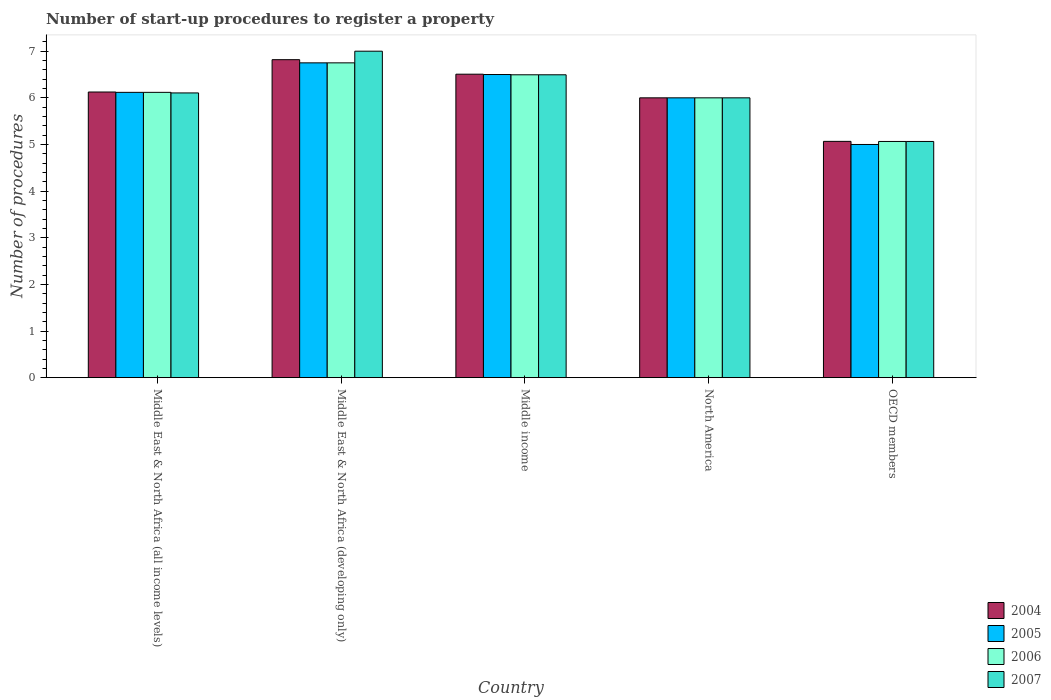How many different coloured bars are there?
Your answer should be compact. 4. Are the number of bars per tick equal to the number of legend labels?
Offer a terse response. Yes. Are the number of bars on each tick of the X-axis equal?
Offer a very short reply. Yes. How many bars are there on the 2nd tick from the right?
Ensure brevity in your answer.  4. What is the label of the 4th group of bars from the left?
Make the answer very short. North America. In how many cases, is the number of bars for a given country not equal to the number of legend labels?
Ensure brevity in your answer.  0. What is the number of procedures required to register a property in 2007 in Middle East & North Africa (all income levels)?
Provide a succinct answer. 6.11. Across all countries, what is the maximum number of procedures required to register a property in 2004?
Provide a succinct answer. 6.82. Across all countries, what is the minimum number of procedures required to register a property in 2006?
Your response must be concise. 5.06. In which country was the number of procedures required to register a property in 2006 maximum?
Keep it short and to the point. Middle East & North Africa (developing only). In which country was the number of procedures required to register a property in 2005 minimum?
Provide a short and direct response. OECD members. What is the total number of procedures required to register a property in 2006 in the graph?
Offer a very short reply. 30.43. What is the difference between the number of procedures required to register a property in 2004 in Middle income and that in North America?
Your answer should be very brief. 0.51. What is the difference between the number of procedures required to register a property in 2007 in Middle income and the number of procedures required to register a property in 2004 in Middle East & North Africa (developing only)?
Offer a very short reply. -0.32. What is the average number of procedures required to register a property in 2005 per country?
Your answer should be compact. 6.07. Is the number of procedures required to register a property in 2004 in Middle East & North Africa (all income levels) less than that in Middle East & North Africa (developing only)?
Provide a succinct answer. Yes. Is the difference between the number of procedures required to register a property in 2005 in Middle income and OECD members greater than the difference between the number of procedures required to register a property in 2006 in Middle income and OECD members?
Offer a very short reply. Yes. What is the difference between the highest and the second highest number of procedures required to register a property in 2005?
Give a very brief answer. -0.63. What is the difference between the highest and the lowest number of procedures required to register a property in 2007?
Offer a very short reply. 1.94. In how many countries, is the number of procedures required to register a property in 2007 greater than the average number of procedures required to register a property in 2007 taken over all countries?
Give a very brief answer. 2. Is it the case that in every country, the sum of the number of procedures required to register a property in 2005 and number of procedures required to register a property in 2007 is greater than the number of procedures required to register a property in 2004?
Your answer should be compact. Yes. How many bars are there?
Your answer should be compact. 20. Are all the bars in the graph horizontal?
Provide a succinct answer. No. How many countries are there in the graph?
Make the answer very short. 5. What is the difference between two consecutive major ticks on the Y-axis?
Provide a succinct answer. 1. Where does the legend appear in the graph?
Give a very brief answer. Bottom right. How many legend labels are there?
Provide a succinct answer. 4. What is the title of the graph?
Offer a terse response. Number of start-up procedures to register a property. What is the label or title of the X-axis?
Provide a short and direct response. Country. What is the label or title of the Y-axis?
Provide a succinct answer. Number of procedures. What is the Number of procedures of 2004 in Middle East & North Africa (all income levels)?
Give a very brief answer. 6.12. What is the Number of procedures in 2005 in Middle East & North Africa (all income levels)?
Your answer should be very brief. 6.12. What is the Number of procedures in 2006 in Middle East & North Africa (all income levels)?
Offer a terse response. 6.12. What is the Number of procedures of 2007 in Middle East & North Africa (all income levels)?
Offer a terse response. 6.11. What is the Number of procedures of 2004 in Middle East & North Africa (developing only)?
Your answer should be very brief. 6.82. What is the Number of procedures of 2005 in Middle East & North Africa (developing only)?
Ensure brevity in your answer.  6.75. What is the Number of procedures in 2006 in Middle East & North Africa (developing only)?
Make the answer very short. 6.75. What is the Number of procedures in 2007 in Middle East & North Africa (developing only)?
Offer a terse response. 7. What is the Number of procedures in 2004 in Middle income?
Provide a succinct answer. 6.51. What is the Number of procedures of 2005 in Middle income?
Offer a terse response. 6.5. What is the Number of procedures in 2006 in Middle income?
Your response must be concise. 6.49. What is the Number of procedures in 2007 in Middle income?
Provide a succinct answer. 6.49. What is the Number of procedures in 2004 in OECD members?
Give a very brief answer. 5.07. What is the Number of procedures of 2005 in OECD members?
Provide a short and direct response. 5. What is the Number of procedures of 2006 in OECD members?
Provide a short and direct response. 5.06. What is the Number of procedures of 2007 in OECD members?
Provide a short and direct response. 5.06. Across all countries, what is the maximum Number of procedures in 2004?
Your answer should be very brief. 6.82. Across all countries, what is the maximum Number of procedures of 2005?
Offer a very short reply. 6.75. Across all countries, what is the maximum Number of procedures of 2006?
Offer a very short reply. 6.75. Across all countries, what is the maximum Number of procedures of 2007?
Offer a terse response. 7. Across all countries, what is the minimum Number of procedures in 2004?
Your answer should be very brief. 5.07. Across all countries, what is the minimum Number of procedures in 2005?
Your response must be concise. 5. Across all countries, what is the minimum Number of procedures of 2006?
Make the answer very short. 5.06. Across all countries, what is the minimum Number of procedures in 2007?
Provide a short and direct response. 5.06. What is the total Number of procedures in 2004 in the graph?
Make the answer very short. 30.52. What is the total Number of procedures in 2005 in the graph?
Keep it short and to the point. 30.37. What is the total Number of procedures of 2006 in the graph?
Make the answer very short. 30.43. What is the total Number of procedures in 2007 in the graph?
Ensure brevity in your answer.  30.66. What is the difference between the Number of procedures in 2004 in Middle East & North Africa (all income levels) and that in Middle East & North Africa (developing only)?
Your answer should be compact. -0.69. What is the difference between the Number of procedures of 2005 in Middle East & North Africa (all income levels) and that in Middle East & North Africa (developing only)?
Make the answer very short. -0.63. What is the difference between the Number of procedures in 2006 in Middle East & North Africa (all income levels) and that in Middle East & North Africa (developing only)?
Provide a short and direct response. -0.63. What is the difference between the Number of procedures in 2007 in Middle East & North Africa (all income levels) and that in Middle East & North Africa (developing only)?
Keep it short and to the point. -0.89. What is the difference between the Number of procedures of 2004 in Middle East & North Africa (all income levels) and that in Middle income?
Give a very brief answer. -0.38. What is the difference between the Number of procedures of 2005 in Middle East & North Africa (all income levels) and that in Middle income?
Keep it short and to the point. -0.38. What is the difference between the Number of procedures of 2006 in Middle East & North Africa (all income levels) and that in Middle income?
Your answer should be compact. -0.38. What is the difference between the Number of procedures in 2007 in Middle East & North Africa (all income levels) and that in Middle income?
Ensure brevity in your answer.  -0.39. What is the difference between the Number of procedures of 2004 in Middle East & North Africa (all income levels) and that in North America?
Offer a very short reply. 0.12. What is the difference between the Number of procedures of 2005 in Middle East & North Africa (all income levels) and that in North America?
Offer a very short reply. 0.12. What is the difference between the Number of procedures of 2006 in Middle East & North Africa (all income levels) and that in North America?
Provide a short and direct response. 0.12. What is the difference between the Number of procedures in 2007 in Middle East & North Africa (all income levels) and that in North America?
Provide a short and direct response. 0.11. What is the difference between the Number of procedures in 2004 in Middle East & North Africa (all income levels) and that in OECD members?
Provide a short and direct response. 1.06. What is the difference between the Number of procedures of 2005 in Middle East & North Africa (all income levels) and that in OECD members?
Provide a short and direct response. 1.12. What is the difference between the Number of procedures in 2006 in Middle East & North Africa (all income levels) and that in OECD members?
Your answer should be compact. 1.05. What is the difference between the Number of procedures in 2007 in Middle East & North Africa (all income levels) and that in OECD members?
Ensure brevity in your answer.  1.04. What is the difference between the Number of procedures of 2004 in Middle East & North Africa (developing only) and that in Middle income?
Offer a terse response. 0.31. What is the difference between the Number of procedures in 2006 in Middle East & North Africa (developing only) and that in Middle income?
Your answer should be compact. 0.26. What is the difference between the Number of procedures in 2007 in Middle East & North Africa (developing only) and that in Middle income?
Provide a succinct answer. 0.51. What is the difference between the Number of procedures in 2004 in Middle East & North Africa (developing only) and that in North America?
Your answer should be compact. 0.82. What is the difference between the Number of procedures of 2006 in Middle East & North Africa (developing only) and that in North America?
Provide a short and direct response. 0.75. What is the difference between the Number of procedures in 2004 in Middle East & North Africa (developing only) and that in OECD members?
Keep it short and to the point. 1.75. What is the difference between the Number of procedures in 2005 in Middle East & North Africa (developing only) and that in OECD members?
Offer a terse response. 1.75. What is the difference between the Number of procedures in 2006 in Middle East & North Africa (developing only) and that in OECD members?
Offer a terse response. 1.69. What is the difference between the Number of procedures of 2007 in Middle East & North Africa (developing only) and that in OECD members?
Your answer should be compact. 1.94. What is the difference between the Number of procedures of 2004 in Middle income and that in North America?
Offer a very short reply. 0.51. What is the difference between the Number of procedures in 2006 in Middle income and that in North America?
Your answer should be very brief. 0.49. What is the difference between the Number of procedures of 2007 in Middle income and that in North America?
Keep it short and to the point. 0.49. What is the difference between the Number of procedures of 2004 in Middle income and that in OECD members?
Your answer should be very brief. 1.44. What is the difference between the Number of procedures in 2006 in Middle income and that in OECD members?
Ensure brevity in your answer.  1.43. What is the difference between the Number of procedures of 2007 in Middle income and that in OECD members?
Ensure brevity in your answer.  1.43. What is the difference between the Number of procedures in 2006 in North America and that in OECD members?
Your answer should be compact. 0.94. What is the difference between the Number of procedures of 2007 in North America and that in OECD members?
Your answer should be compact. 0.94. What is the difference between the Number of procedures of 2004 in Middle East & North Africa (all income levels) and the Number of procedures of 2005 in Middle East & North Africa (developing only)?
Make the answer very short. -0.62. What is the difference between the Number of procedures in 2004 in Middle East & North Africa (all income levels) and the Number of procedures in 2006 in Middle East & North Africa (developing only)?
Make the answer very short. -0.62. What is the difference between the Number of procedures of 2004 in Middle East & North Africa (all income levels) and the Number of procedures of 2007 in Middle East & North Africa (developing only)?
Make the answer very short. -0.88. What is the difference between the Number of procedures in 2005 in Middle East & North Africa (all income levels) and the Number of procedures in 2006 in Middle East & North Africa (developing only)?
Offer a very short reply. -0.63. What is the difference between the Number of procedures of 2005 in Middle East & North Africa (all income levels) and the Number of procedures of 2007 in Middle East & North Africa (developing only)?
Offer a very short reply. -0.88. What is the difference between the Number of procedures in 2006 in Middle East & North Africa (all income levels) and the Number of procedures in 2007 in Middle East & North Africa (developing only)?
Your response must be concise. -0.88. What is the difference between the Number of procedures of 2004 in Middle East & North Africa (all income levels) and the Number of procedures of 2005 in Middle income?
Your response must be concise. -0.38. What is the difference between the Number of procedures in 2004 in Middle East & North Africa (all income levels) and the Number of procedures in 2006 in Middle income?
Ensure brevity in your answer.  -0.37. What is the difference between the Number of procedures of 2004 in Middle East & North Africa (all income levels) and the Number of procedures of 2007 in Middle income?
Offer a very short reply. -0.37. What is the difference between the Number of procedures in 2005 in Middle East & North Africa (all income levels) and the Number of procedures in 2006 in Middle income?
Provide a short and direct response. -0.38. What is the difference between the Number of procedures of 2005 in Middle East & North Africa (all income levels) and the Number of procedures of 2007 in Middle income?
Your response must be concise. -0.38. What is the difference between the Number of procedures of 2006 in Middle East & North Africa (all income levels) and the Number of procedures of 2007 in Middle income?
Give a very brief answer. -0.38. What is the difference between the Number of procedures in 2004 in Middle East & North Africa (all income levels) and the Number of procedures in 2005 in North America?
Give a very brief answer. 0.12. What is the difference between the Number of procedures in 2004 in Middle East & North Africa (all income levels) and the Number of procedures in 2006 in North America?
Offer a very short reply. 0.12. What is the difference between the Number of procedures of 2005 in Middle East & North Africa (all income levels) and the Number of procedures of 2006 in North America?
Provide a short and direct response. 0.12. What is the difference between the Number of procedures of 2005 in Middle East & North Africa (all income levels) and the Number of procedures of 2007 in North America?
Your response must be concise. 0.12. What is the difference between the Number of procedures in 2006 in Middle East & North Africa (all income levels) and the Number of procedures in 2007 in North America?
Your answer should be very brief. 0.12. What is the difference between the Number of procedures in 2004 in Middle East & North Africa (all income levels) and the Number of procedures in 2005 in OECD members?
Offer a terse response. 1.12. What is the difference between the Number of procedures in 2004 in Middle East & North Africa (all income levels) and the Number of procedures in 2006 in OECD members?
Your answer should be very brief. 1.06. What is the difference between the Number of procedures in 2004 in Middle East & North Africa (all income levels) and the Number of procedures in 2007 in OECD members?
Make the answer very short. 1.06. What is the difference between the Number of procedures of 2005 in Middle East & North Africa (all income levels) and the Number of procedures of 2006 in OECD members?
Offer a terse response. 1.05. What is the difference between the Number of procedures of 2005 in Middle East & North Africa (all income levels) and the Number of procedures of 2007 in OECD members?
Offer a very short reply. 1.05. What is the difference between the Number of procedures of 2006 in Middle East & North Africa (all income levels) and the Number of procedures of 2007 in OECD members?
Offer a terse response. 1.05. What is the difference between the Number of procedures of 2004 in Middle East & North Africa (developing only) and the Number of procedures of 2005 in Middle income?
Provide a short and direct response. 0.32. What is the difference between the Number of procedures of 2004 in Middle East & North Africa (developing only) and the Number of procedures of 2006 in Middle income?
Provide a succinct answer. 0.32. What is the difference between the Number of procedures in 2004 in Middle East & North Africa (developing only) and the Number of procedures in 2007 in Middle income?
Ensure brevity in your answer.  0.32. What is the difference between the Number of procedures of 2005 in Middle East & North Africa (developing only) and the Number of procedures of 2006 in Middle income?
Give a very brief answer. 0.26. What is the difference between the Number of procedures in 2005 in Middle East & North Africa (developing only) and the Number of procedures in 2007 in Middle income?
Provide a short and direct response. 0.26. What is the difference between the Number of procedures of 2006 in Middle East & North Africa (developing only) and the Number of procedures of 2007 in Middle income?
Your response must be concise. 0.26. What is the difference between the Number of procedures in 2004 in Middle East & North Africa (developing only) and the Number of procedures in 2005 in North America?
Your answer should be compact. 0.82. What is the difference between the Number of procedures in 2004 in Middle East & North Africa (developing only) and the Number of procedures in 2006 in North America?
Offer a very short reply. 0.82. What is the difference between the Number of procedures of 2004 in Middle East & North Africa (developing only) and the Number of procedures of 2007 in North America?
Make the answer very short. 0.82. What is the difference between the Number of procedures of 2005 in Middle East & North Africa (developing only) and the Number of procedures of 2006 in North America?
Provide a short and direct response. 0.75. What is the difference between the Number of procedures of 2005 in Middle East & North Africa (developing only) and the Number of procedures of 2007 in North America?
Your response must be concise. 0.75. What is the difference between the Number of procedures of 2006 in Middle East & North Africa (developing only) and the Number of procedures of 2007 in North America?
Your answer should be compact. 0.75. What is the difference between the Number of procedures of 2004 in Middle East & North Africa (developing only) and the Number of procedures of 2005 in OECD members?
Provide a short and direct response. 1.82. What is the difference between the Number of procedures in 2004 in Middle East & North Africa (developing only) and the Number of procedures in 2006 in OECD members?
Keep it short and to the point. 1.75. What is the difference between the Number of procedures of 2004 in Middle East & North Africa (developing only) and the Number of procedures of 2007 in OECD members?
Your response must be concise. 1.75. What is the difference between the Number of procedures in 2005 in Middle East & North Africa (developing only) and the Number of procedures in 2006 in OECD members?
Offer a very short reply. 1.69. What is the difference between the Number of procedures of 2005 in Middle East & North Africa (developing only) and the Number of procedures of 2007 in OECD members?
Provide a short and direct response. 1.69. What is the difference between the Number of procedures of 2006 in Middle East & North Africa (developing only) and the Number of procedures of 2007 in OECD members?
Make the answer very short. 1.69. What is the difference between the Number of procedures of 2004 in Middle income and the Number of procedures of 2005 in North America?
Your response must be concise. 0.51. What is the difference between the Number of procedures of 2004 in Middle income and the Number of procedures of 2006 in North America?
Provide a succinct answer. 0.51. What is the difference between the Number of procedures in 2004 in Middle income and the Number of procedures in 2007 in North America?
Ensure brevity in your answer.  0.51. What is the difference between the Number of procedures of 2006 in Middle income and the Number of procedures of 2007 in North America?
Offer a terse response. 0.49. What is the difference between the Number of procedures of 2004 in Middle income and the Number of procedures of 2005 in OECD members?
Your answer should be compact. 1.51. What is the difference between the Number of procedures of 2004 in Middle income and the Number of procedures of 2006 in OECD members?
Your answer should be very brief. 1.44. What is the difference between the Number of procedures in 2004 in Middle income and the Number of procedures in 2007 in OECD members?
Make the answer very short. 1.44. What is the difference between the Number of procedures of 2005 in Middle income and the Number of procedures of 2006 in OECD members?
Give a very brief answer. 1.44. What is the difference between the Number of procedures of 2005 in Middle income and the Number of procedures of 2007 in OECD members?
Give a very brief answer. 1.44. What is the difference between the Number of procedures of 2006 in Middle income and the Number of procedures of 2007 in OECD members?
Ensure brevity in your answer.  1.43. What is the difference between the Number of procedures in 2004 in North America and the Number of procedures in 2006 in OECD members?
Your response must be concise. 0.94. What is the difference between the Number of procedures of 2004 in North America and the Number of procedures of 2007 in OECD members?
Provide a succinct answer. 0.94. What is the difference between the Number of procedures in 2005 in North America and the Number of procedures in 2006 in OECD members?
Offer a terse response. 0.94. What is the difference between the Number of procedures of 2005 in North America and the Number of procedures of 2007 in OECD members?
Offer a terse response. 0.94. What is the difference between the Number of procedures of 2006 in North America and the Number of procedures of 2007 in OECD members?
Offer a very short reply. 0.94. What is the average Number of procedures in 2004 per country?
Keep it short and to the point. 6.1. What is the average Number of procedures in 2005 per country?
Offer a very short reply. 6.07. What is the average Number of procedures of 2006 per country?
Give a very brief answer. 6.09. What is the average Number of procedures in 2007 per country?
Ensure brevity in your answer.  6.13. What is the difference between the Number of procedures of 2004 and Number of procedures of 2005 in Middle East & North Africa (all income levels)?
Your answer should be compact. 0.01. What is the difference between the Number of procedures in 2004 and Number of procedures in 2006 in Middle East & North Africa (all income levels)?
Offer a very short reply. 0.01. What is the difference between the Number of procedures in 2004 and Number of procedures in 2007 in Middle East & North Africa (all income levels)?
Provide a short and direct response. 0.02. What is the difference between the Number of procedures of 2005 and Number of procedures of 2007 in Middle East & North Africa (all income levels)?
Your answer should be very brief. 0.01. What is the difference between the Number of procedures in 2006 and Number of procedures in 2007 in Middle East & North Africa (all income levels)?
Your answer should be very brief. 0.01. What is the difference between the Number of procedures of 2004 and Number of procedures of 2005 in Middle East & North Africa (developing only)?
Ensure brevity in your answer.  0.07. What is the difference between the Number of procedures of 2004 and Number of procedures of 2006 in Middle East & North Africa (developing only)?
Your answer should be very brief. 0.07. What is the difference between the Number of procedures in 2004 and Number of procedures in 2007 in Middle East & North Africa (developing only)?
Offer a terse response. -0.18. What is the difference between the Number of procedures in 2005 and Number of procedures in 2007 in Middle East & North Africa (developing only)?
Offer a terse response. -0.25. What is the difference between the Number of procedures in 2004 and Number of procedures in 2005 in Middle income?
Ensure brevity in your answer.  0.01. What is the difference between the Number of procedures of 2004 and Number of procedures of 2006 in Middle income?
Your answer should be very brief. 0.01. What is the difference between the Number of procedures in 2004 and Number of procedures in 2007 in Middle income?
Provide a short and direct response. 0.01. What is the difference between the Number of procedures of 2005 and Number of procedures of 2006 in Middle income?
Make the answer very short. 0.01. What is the difference between the Number of procedures in 2005 and Number of procedures in 2007 in Middle income?
Ensure brevity in your answer.  0.01. What is the difference between the Number of procedures in 2006 and Number of procedures in 2007 in Middle income?
Provide a short and direct response. 0. What is the difference between the Number of procedures of 2004 and Number of procedures of 2006 in North America?
Give a very brief answer. 0. What is the difference between the Number of procedures of 2004 and Number of procedures of 2007 in North America?
Offer a very short reply. 0. What is the difference between the Number of procedures in 2005 and Number of procedures in 2006 in North America?
Ensure brevity in your answer.  0. What is the difference between the Number of procedures of 2006 and Number of procedures of 2007 in North America?
Your answer should be compact. 0. What is the difference between the Number of procedures in 2004 and Number of procedures in 2005 in OECD members?
Make the answer very short. 0.07. What is the difference between the Number of procedures in 2004 and Number of procedures in 2006 in OECD members?
Give a very brief answer. 0. What is the difference between the Number of procedures of 2004 and Number of procedures of 2007 in OECD members?
Make the answer very short. 0. What is the difference between the Number of procedures of 2005 and Number of procedures of 2006 in OECD members?
Keep it short and to the point. -0.06. What is the difference between the Number of procedures of 2005 and Number of procedures of 2007 in OECD members?
Provide a short and direct response. -0.06. What is the difference between the Number of procedures in 2006 and Number of procedures in 2007 in OECD members?
Offer a very short reply. 0. What is the ratio of the Number of procedures in 2004 in Middle East & North Africa (all income levels) to that in Middle East & North Africa (developing only)?
Offer a very short reply. 0.9. What is the ratio of the Number of procedures in 2005 in Middle East & North Africa (all income levels) to that in Middle East & North Africa (developing only)?
Make the answer very short. 0.91. What is the ratio of the Number of procedures in 2006 in Middle East & North Africa (all income levels) to that in Middle East & North Africa (developing only)?
Provide a short and direct response. 0.91. What is the ratio of the Number of procedures of 2007 in Middle East & North Africa (all income levels) to that in Middle East & North Africa (developing only)?
Give a very brief answer. 0.87. What is the ratio of the Number of procedures in 2004 in Middle East & North Africa (all income levels) to that in Middle income?
Your answer should be very brief. 0.94. What is the ratio of the Number of procedures in 2005 in Middle East & North Africa (all income levels) to that in Middle income?
Offer a terse response. 0.94. What is the ratio of the Number of procedures of 2006 in Middle East & North Africa (all income levels) to that in Middle income?
Your answer should be very brief. 0.94. What is the ratio of the Number of procedures in 2007 in Middle East & North Africa (all income levels) to that in Middle income?
Your answer should be compact. 0.94. What is the ratio of the Number of procedures in 2004 in Middle East & North Africa (all income levels) to that in North America?
Offer a very short reply. 1.02. What is the ratio of the Number of procedures of 2005 in Middle East & North Africa (all income levels) to that in North America?
Provide a short and direct response. 1.02. What is the ratio of the Number of procedures in 2006 in Middle East & North Africa (all income levels) to that in North America?
Offer a terse response. 1.02. What is the ratio of the Number of procedures in 2007 in Middle East & North Africa (all income levels) to that in North America?
Provide a short and direct response. 1.02. What is the ratio of the Number of procedures of 2004 in Middle East & North Africa (all income levels) to that in OECD members?
Make the answer very short. 1.21. What is the ratio of the Number of procedures in 2005 in Middle East & North Africa (all income levels) to that in OECD members?
Give a very brief answer. 1.22. What is the ratio of the Number of procedures of 2006 in Middle East & North Africa (all income levels) to that in OECD members?
Keep it short and to the point. 1.21. What is the ratio of the Number of procedures of 2007 in Middle East & North Africa (all income levels) to that in OECD members?
Make the answer very short. 1.21. What is the ratio of the Number of procedures of 2004 in Middle East & North Africa (developing only) to that in Middle income?
Ensure brevity in your answer.  1.05. What is the ratio of the Number of procedures in 2006 in Middle East & North Africa (developing only) to that in Middle income?
Give a very brief answer. 1.04. What is the ratio of the Number of procedures in 2007 in Middle East & North Africa (developing only) to that in Middle income?
Offer a very short reply. 1.08. What is the ratio of the Number of procedures of 2004 in Middle East & North Africa (developing only) to that in North America?
Your answer should be very brief. 1.14. What is the ratio of the Number of procedures in 2005 in Middle East & North Africa (developing only) to that in North America?
Provide a succinct answer. 1.12. What is the ratio of the Number of procedures in 2007 in Middle East & North Africa (developing only) to that in North America?
Give a very brief answer. 1.17. What is the ratio of the Number of procedures in 2004 in Middle East & North Africa (developing only) to that in OECD members?
Offer a terse response. 1.35. What is the ratio of the Number of procedures of 2005 in Middle East & North Africa (developing only) to that in OECD members?
Keep it short and to the point. 1.35. What is the ratio of the Number of procedures in 2006 in Middle East & North Africa (developing only) to that in OECD members?
Your answer should be very brief. 1.33. What is the ratio of the Number of procedures of 2007 in Middle East & North Africa (developing only) to that in OECD members?
Offer a very short reply. 1.38. What is the ratio of the Number of procedures of 2004 in Middle income to that in North America?
Ensure brevity in your answer.  1.08. What is the ratio of the Number of procedures in 2005 in Middle income to that in North America?
Ensure brevity in your answer.  1.08. What is the ratio of the Number of procedures in 2006 in Middle income to that in North America?
Your response must be concise. 1.08. What is the ratio of the Number of procedures in 2007 in Middle income to that in North America?
Give a very brief answer. 1.08. What is the ratio of the Number of procedures of 2004 in Middle income to that in OECD members?
Provide a succinct answer. 1.28. What is the ratio of the Number of procedures of 2005 in Middle income to that in OECD members?
Your response must be concise. 1.3. What is the ratio of the Number of procedures in 2006 in Middle income to that in OECD members?
Your answer should be compact. 1.28. What is the ratio of the Number of procedures of 2007 in Middle income to that in OECD members?
Your answer should be very brief. 1.28. What is the ratio of the Number of procedures of 2004 in North America to that in OECD members?
Give a very brief answer. 1.18. What is the ratio of the Number of procedures of 2005 in North America to that in OECD members?
Provide a short and direct response. 1.2. What is the ratio of the Number of procedures of 2006 in North America to that in OECD members?
Your answer should be compact. 1.18. What is the ratio of the Number of procedures in 2007 in North America to that in OECD members?
Your answer should be compact. 1.18. What is the difference between the highest and the second highest Number of procedures in 2004?
Give a very brief answer. 0.31. What is the difference between the highest and the second highest Number of procedures in 2005?
Keep it short and to the point. 0.25. What is the difference between the highest and the second highest Number of procedures in 2006?
Offer a terse response. 0.26. What is the difference between the highest and the second highest Number of procedures in 2007?
Keep it short and to the point. 0.51. What is the difference between the highest and the lowest Number of procedures of 2004?
Ensure brevity in your answer.  1.75. What is the difference between the highest and the lowest Number of procedures of 2005?
Provide a short and direct response. 1.75. What is the difference between the highest and the lowest Number of procedures in 2006?
Keep it short and to the point. 1.69. What is the difference between the highest and the lowest Number of procedures of 2007?
Provide a succinct answer. 1.94. 